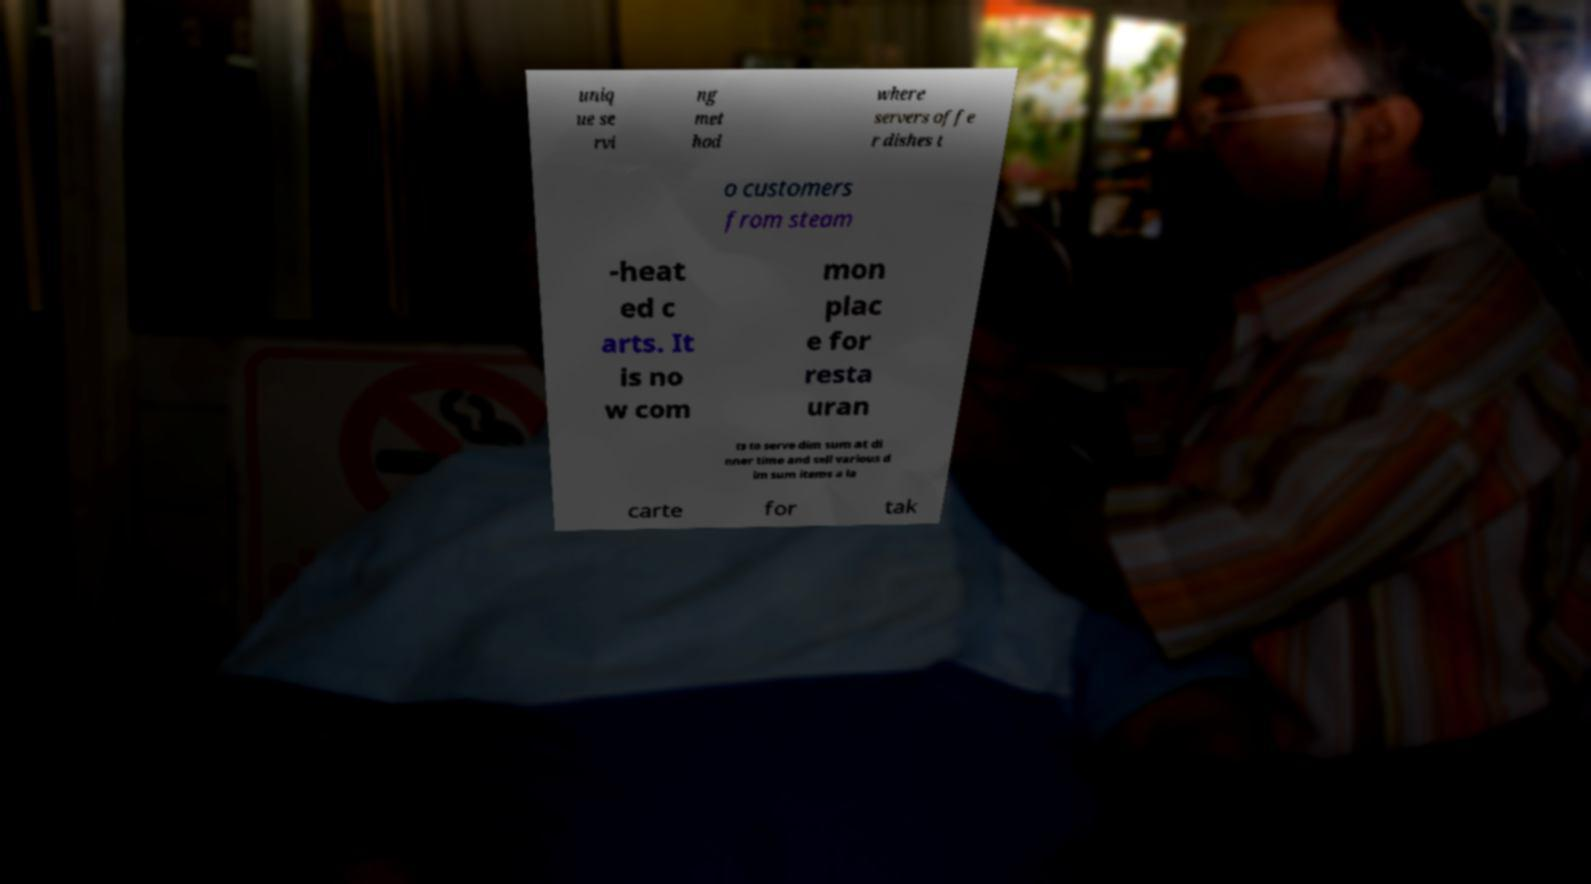Could you assist in decoding the text presented in this image and type it out clearly? uniq ue se rvi ng met hod where servers offe r dishes t o customers from steam -heat ed c arts. It is no w com mon plac e for resta uran ts to serve dim sum at di nner time and sell various d im sum items a la carte for tak 